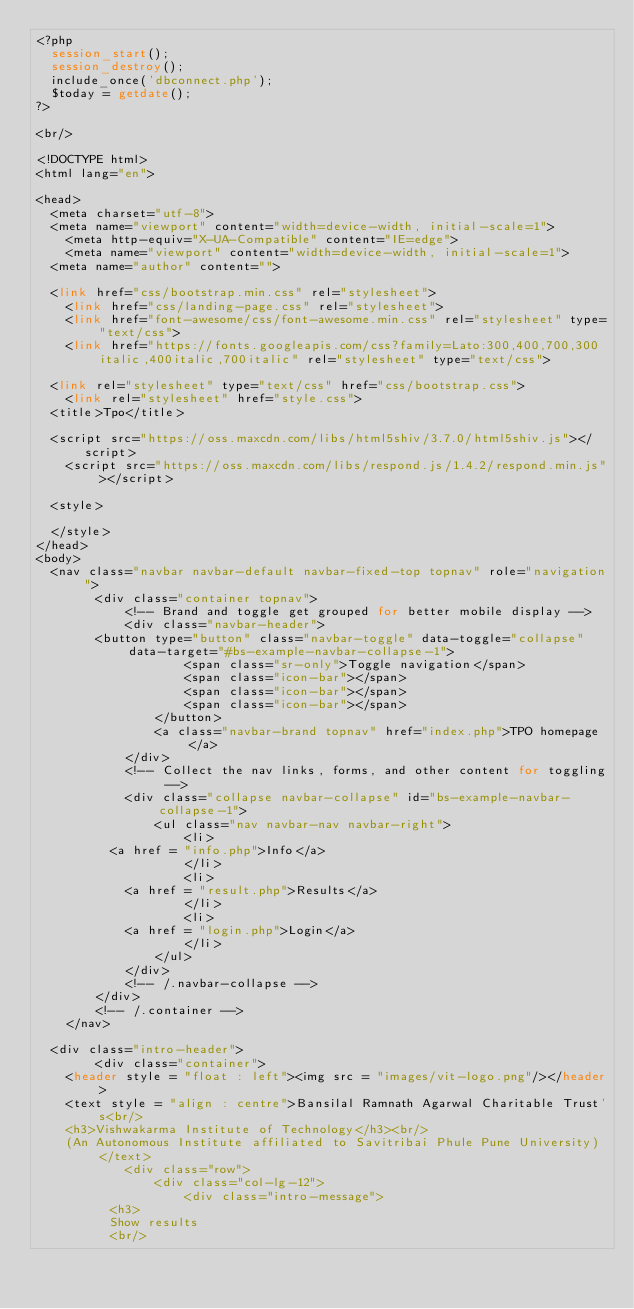Convert code to text. <code><loc_0><loc_0><loc_500><loc_500><_PHP_><?php
	session_start();
	session_destroy();
	include_once('dbconnect.php');
	$today = getdate();
?>

<br/>

<!DOCTYPE html>
<html lang="en">

<head>
	<meta charset="utf-8">
	<meta name="viewport" content="width=device-width, initial-scale=1">
    <meta http-equiv="X-UA-Compatible" content="IE=edge">
    <meta name="viewport" content="width=device-width, initial-scale=1">
	<meta name="author" content="">
	
	<link href="css/bootstrap.min.css" rel="stylesheet">
    <link href="css/landing-page.css" rel="stylesheet">
    <link href="font-awesome/css/font-awesome.min.css" rel="stylesheet" type="text/css">
    <link href="https://fonts.googleapis.com/css?family=Lato:300,400,700,300italic,400italic,700italic" rel="stylesheet" type="text/css">
	
	<link rel="stylesheet" type="text/css" href="css/bootstrap.css">
    <link rel="stylesheet" href="style.css">
	<title>Tpo</title>
	
	<script src="https://oss.maxcdn.com/libs/html5shiv/3.7.0/html5shiv.js"></script>
    <script src="https://oss.maxcdn.com/libs/respond.js/1.4.2/respond.min.js"></script>
	
	<style>
		
	</style>
</head>
<body>
	<nav class="navbar navbar-default navbar-fixed-top topnav" role="navigation">
        <div class="container topnav">
            <!-- Brand and toggle get grouped for better mobile display -->
            <div class="navbar-header">
				<button type="button" class="navbar-toggle" data-toggle="collapse" data-target="#bs-example-navbar-collapse-1">
                    <span class="sr-only">Toggle navigation</span>
                    <span class="icon-bar"></span>
                    <span class="icon-bar"></span>
                    <span class="icon-bar"></span>
                </button>
                <a class="navbar-brand topnav" href="index.php">TPO homepage</a>
            </div>
            <!-- Collect the nav links, forms, and other content for toggling -->
            <div class="collapse navbar-collapse" id="bs-example-navbar-collapse-1">
                <ul class="nav navbar-nav navbar-right">
                    <li>
					<a href = "info.php">Info</a>
                    </li>
                    <li>
						<a href = "result.php">Results</a>			
                    </li>
                    <li>
						<a href = "login.php">Login</a>
                    </li>
                </ul>
            </div>
            <!-- /.navbar-collapse -->
        </div>
        <!-- /.container -->
    </nav>
	
	<div class="intro-header">
        <div class="container">
		<header style = "float : left"><img src = "images/vit-logo.png"/></header>	
		<text style = "align : centre">Bansilal Ramnath Agarwal Charitable Trust's<br/>
		<h3>Vishwakarma Institute of Technology</h3><br/>
		(An Autonomous Institute affiliated to Savitribai Phule Pune University)</text>
            <div class="row">
                <div class="col-lg-12">
                    <div class="intro-message">
					<h3>
					Show results
					<br/></code> 